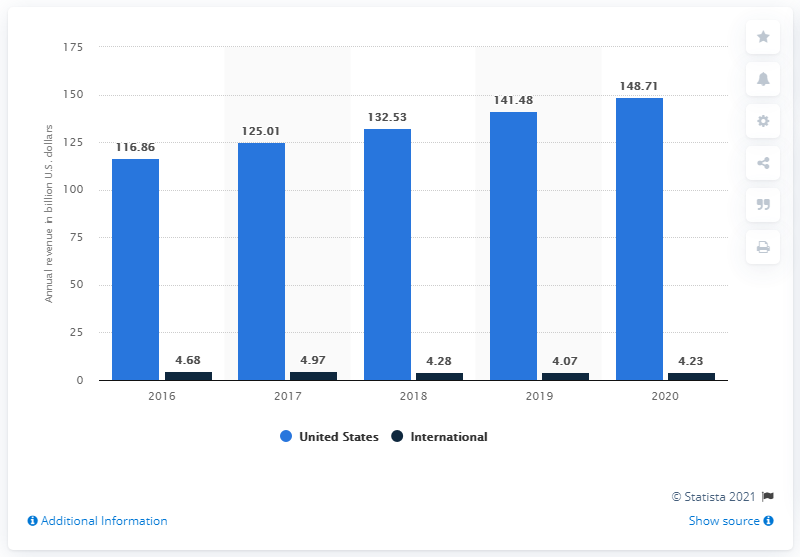Indicate a few pertinent items in this graphic. In Fiscal Year 2020, Cardinal Health generated revenue of 148.71 billion dollars in the United States. 